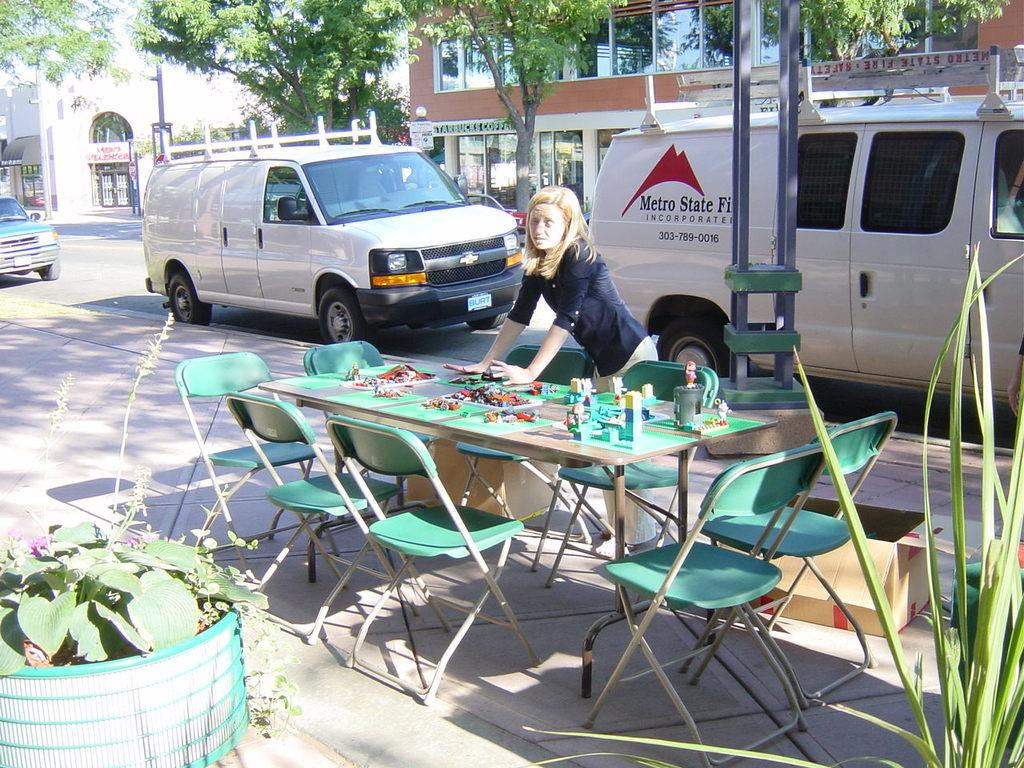Provide a one-sentence caption for the provided image. The white van on the road is Metro State. 